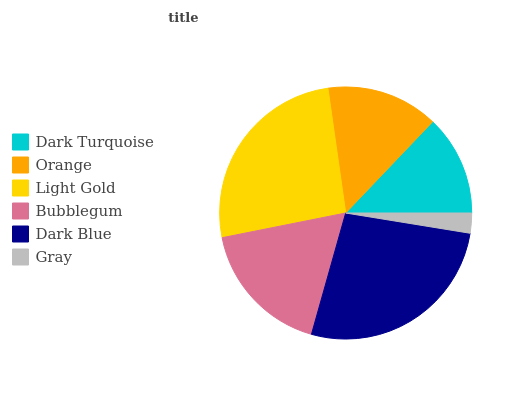Is Gray the minimum?
Answer yes or no. Yes. Is Dark Blue the maximum?
Answer yes or no. Yes. Is Orange the minimum?
Answer yes or no. No. Is Orange the maximum?
Answer yes or no. No. Is Orange greater than Dark Turquoise?
Answer yes or no. Yes. Is Dark Turquoise less than Orange?
Answer yes or no. Yes. Is Dark Turquoise greater than Orange?
Answer yes or no. No. Is Orange less than Dark Turquoise?
Answer yes or no. No. Is Bubblegum the high median?
Answer yes or no. Yes. Is Orange the low median?
Answer yes or no. Yes. Is Orange the high median?
Answer yes or no. No. Is Gray the low median?
Answer yes or no. No. 